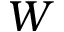Convert formula to latex. <formula><loc_0><loc_0><loc_500><loc_500>W</formula> 